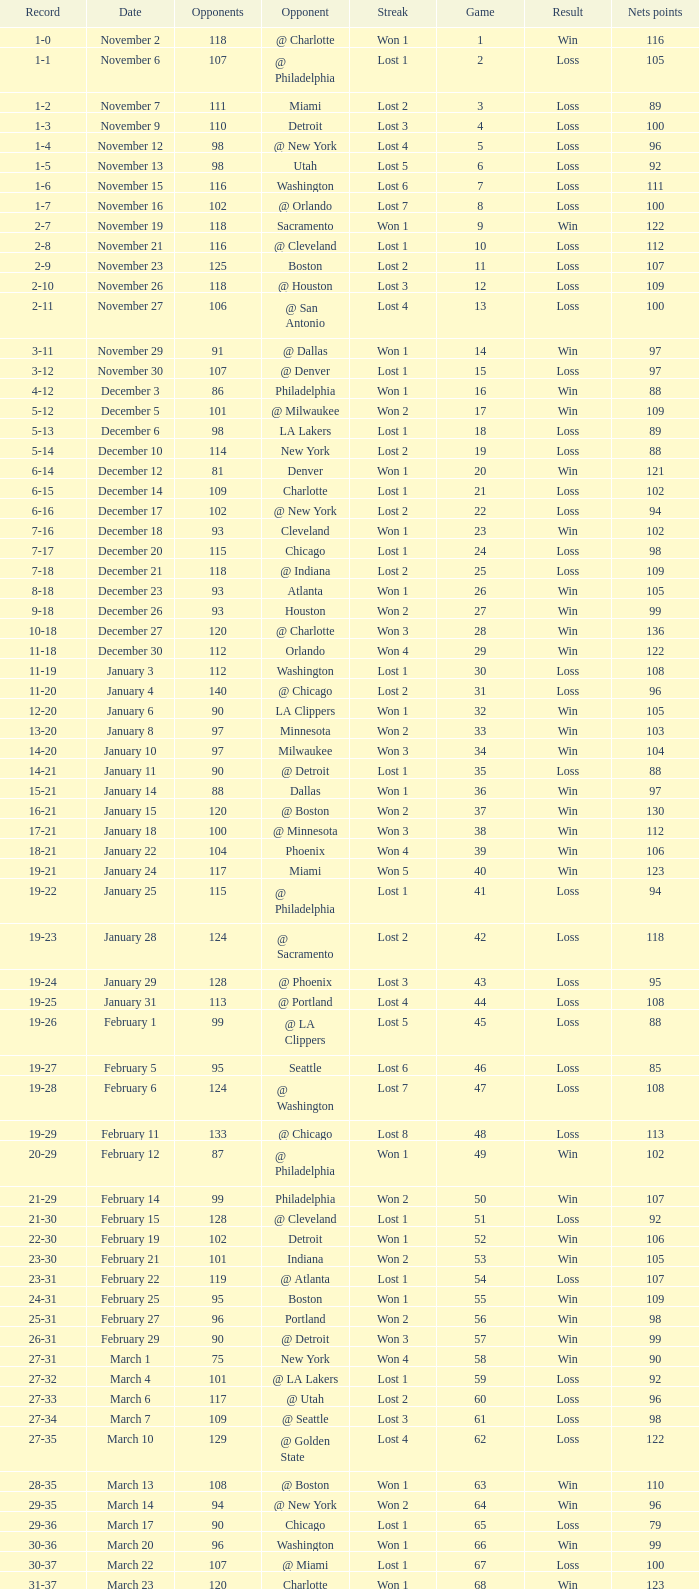Which opponent is from february 12? @ Philadelphia. 